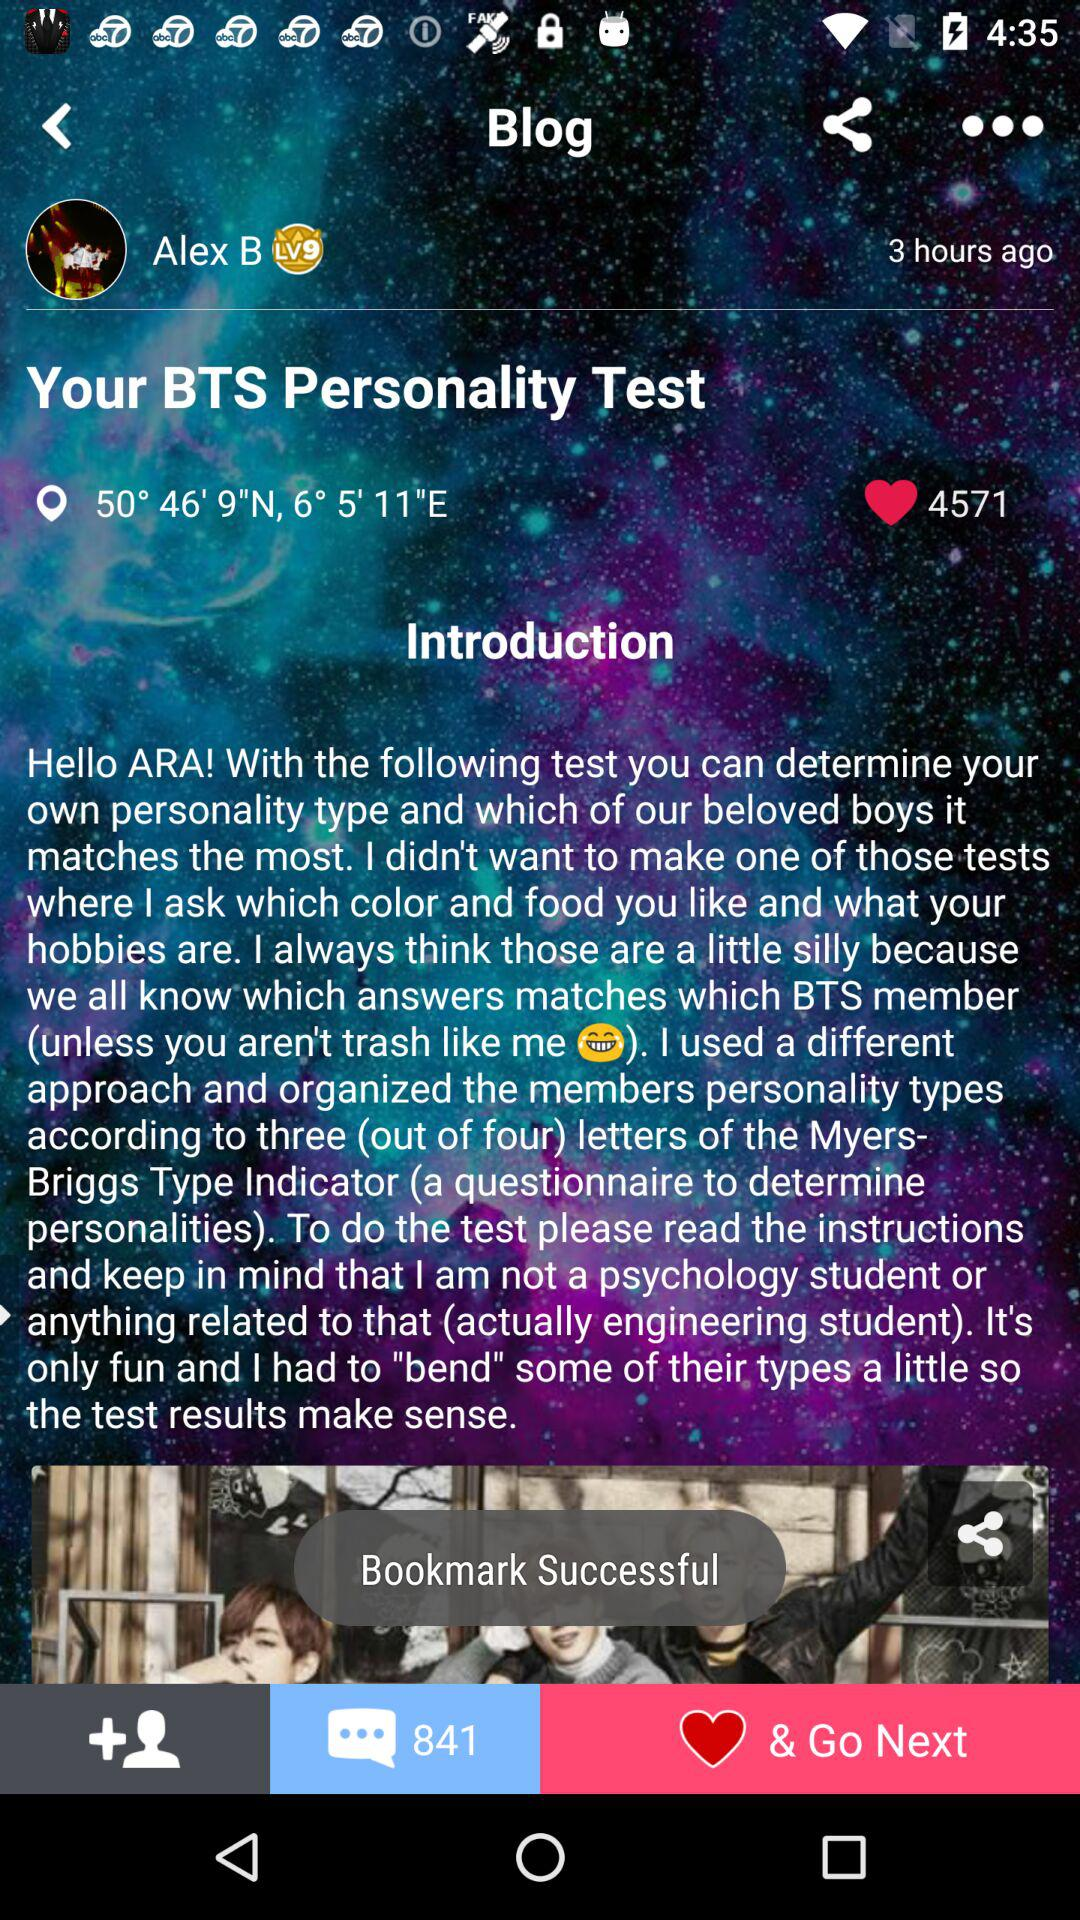How many people have liked the blog? There are 4571 people who have liked the blog. 